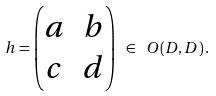Convert formula to latex. <formula><loc_0><loc_0><loc_500><loc_500>h = \begin{pmatrix} a & b \\ c & d \end{pmatrix} \ \in \ O ( D , D ) \, .</formula> 